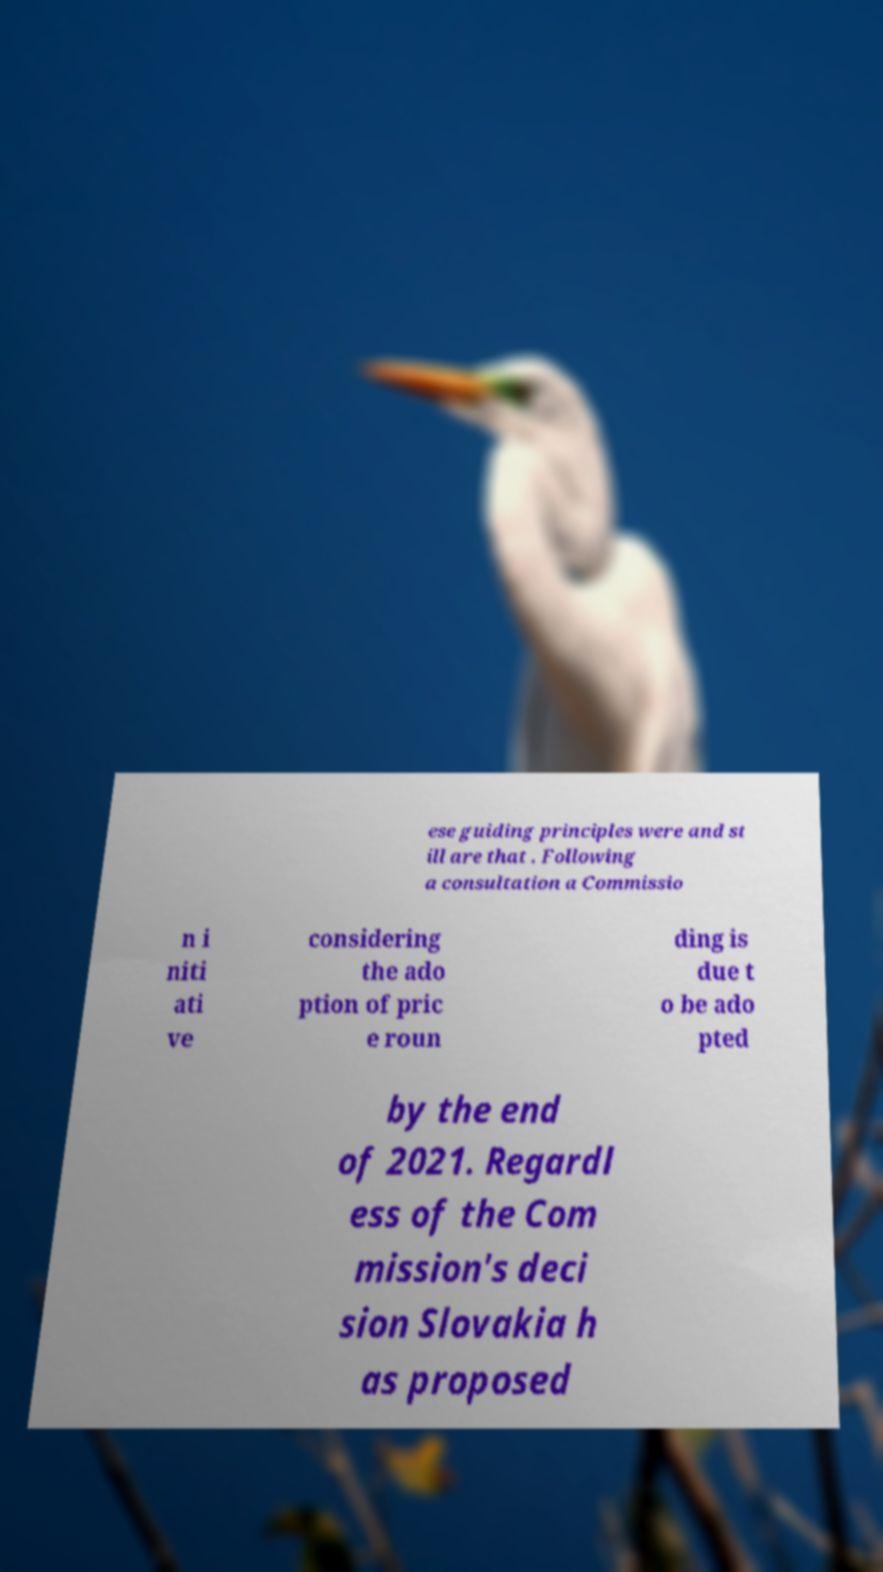Could you extract and type out the text from this image? ese guiding principles were and st ill are that . Following a consultation a Commissio n i niti ati ve considering the ado ption of pric e roun ding is due t o be ado pted by the end of 2021. Regardl ess of the Com mission's deci sion Slovakia h as proposed 